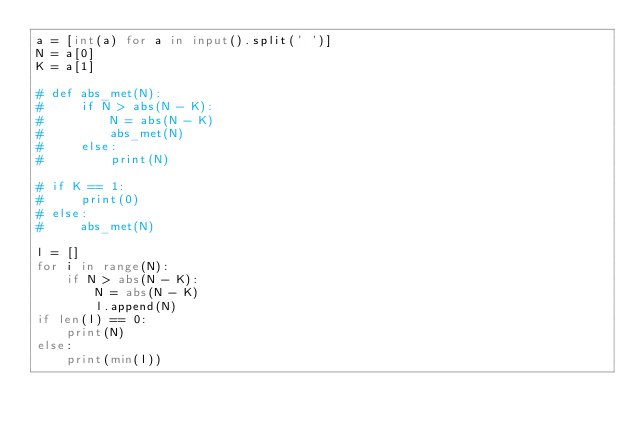Convert code to text. <code><loc_0><loc_0><loc_500><loc_500><_Python_>a = [int(a) for a in input().split(' ')]
N = a[0]
K = a[1]
    
# def abs_met(N):
#     if N > abs(N - K):
#         N = abs(N - K)
#         abs_met(N)
#     else:
#         print(N)
        
# if K == 1:
#     print(0)
# else:
#     abs_met(N)

l = []
for i in range(N):
    if N > abs(N - K):
        N = abs(N - K)
        l.append(N)
if len(l) == 0:
    print(N)
else:
    print(min(l))</code> 